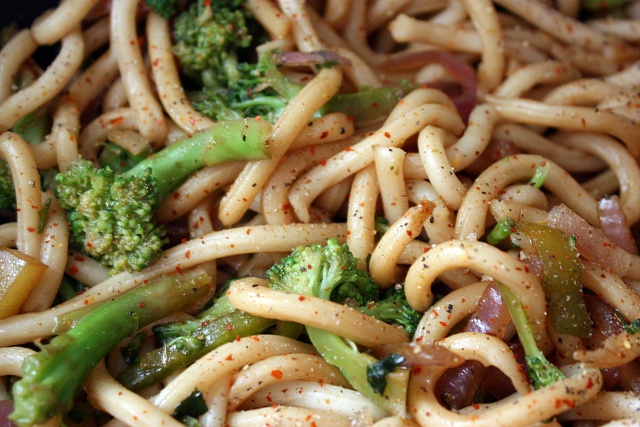Describe the objects in this image and their specific colors. I can see broccoli in black, olive, and darkgreen tones, broccoli in black, olive, and darkgreen tones, broccoli in black, darkgreen, and olive tones, and broccoli in black, olive, darkgreen, and khaki tones in this image. 